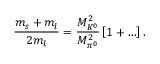<formula> <loc_0><loc_0><loc_500><loc_500>\frac { m _ { s } + m _ { l } } { 2 m _ { l } } = \frac { M _ { K ^ { 0 } } ^ { 2 } } { M _ { \pi ^ { 0 } } ^ { 2 } } \left [ 1 + \dots \right ] .</formula> 